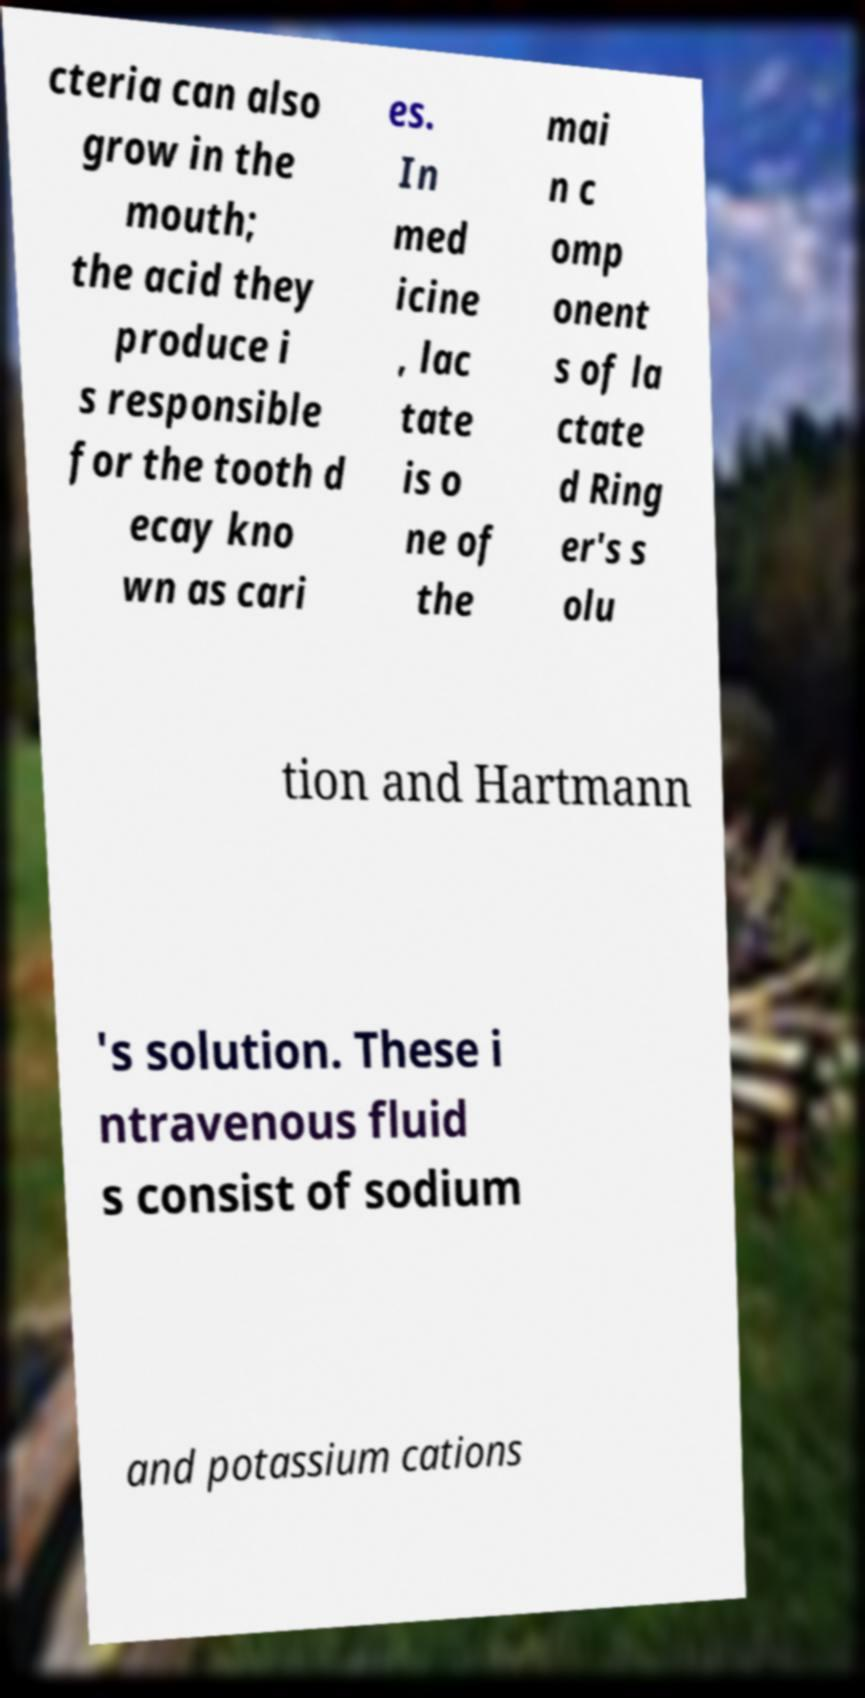Please read and relay the text visible in this image. What does it say? cteria can also grow in the mouth; the acid they produce i s responsible for the tooth d ecay kno wn as cari es. In med icine , lac tate is o ne of the mai n c omp onent s of la ctate d Ring er's s olu tion and Hartmann 's solution. These i ntravenous fluid s consist of sodium and potassium cations 